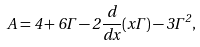<formula> <loc_0><loc_0><loc_500><loc_500>A = 4 + 6 \Gamma - 2 \frac { d } { d x } ( x \Gamma ) - 3 \Gamma ^ { 2 } ,</formula> 